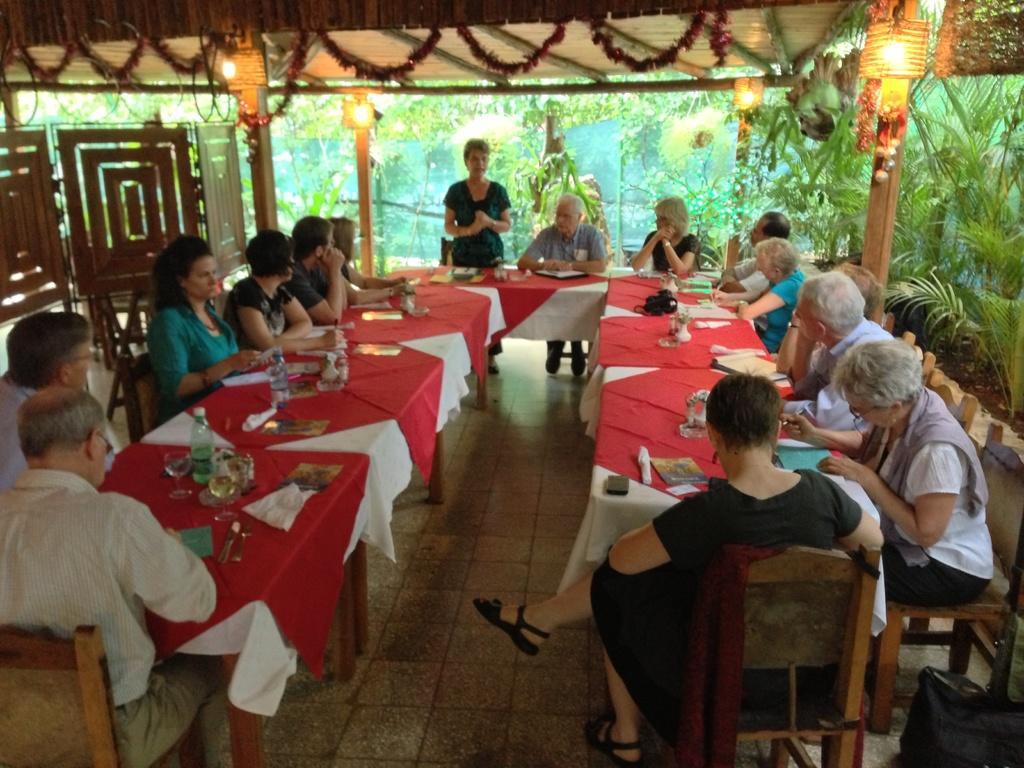Describe this image in one or two sentences. There are group of people sitting in chairs and there is a table in front of them which has some objects on it and the women wearing green dress is standing in front of them. 